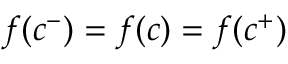<formula> <loc_0><loc_0><loc_500><loc_500>f ( c ^ { - } ) = f ( c ) = f ( c ^ { + } )</formula> 